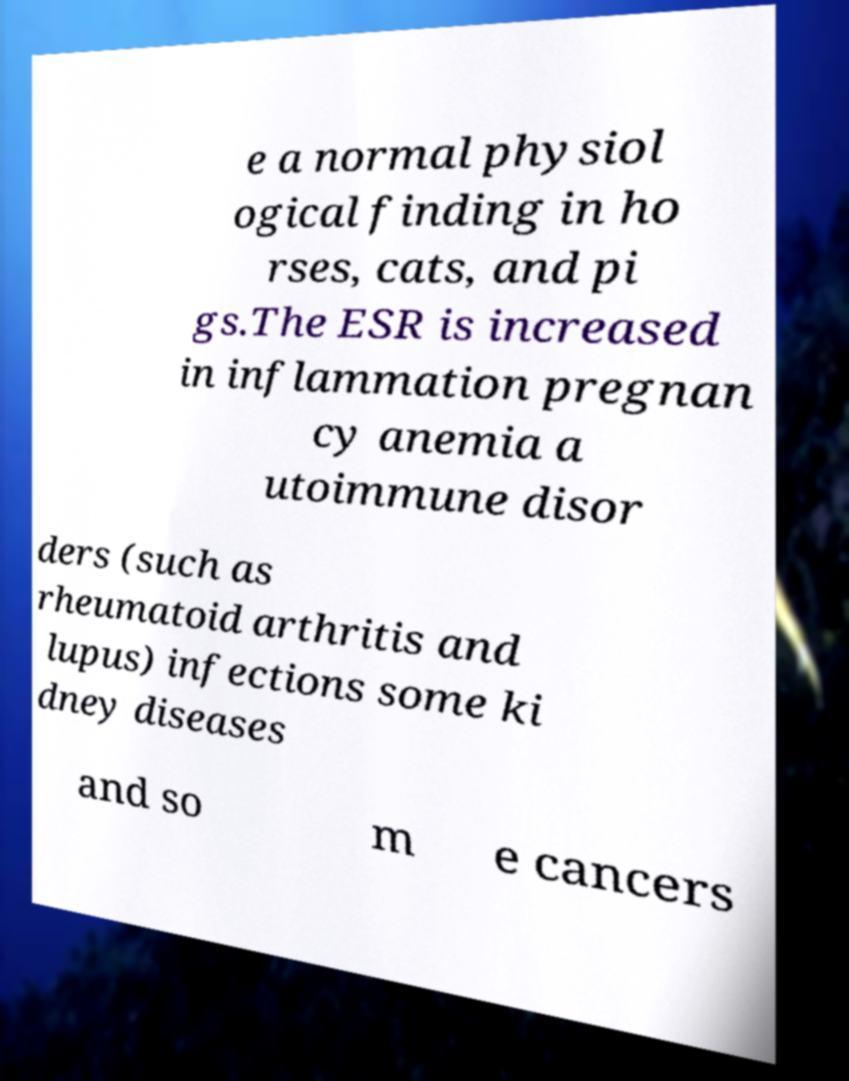Can you read and provide the text displayed in the image?This photo seems to have some interesting text. Can you extract and type it out for me? e a normal physiol ogical finding in ho rses, cats, and pi gs.The ESR is increased in inflammation pregnan cy anemia a utoimmune disor ders (such as rheumatoid arthritis and lupus) infections some ki dney diseases and so m e cancers 